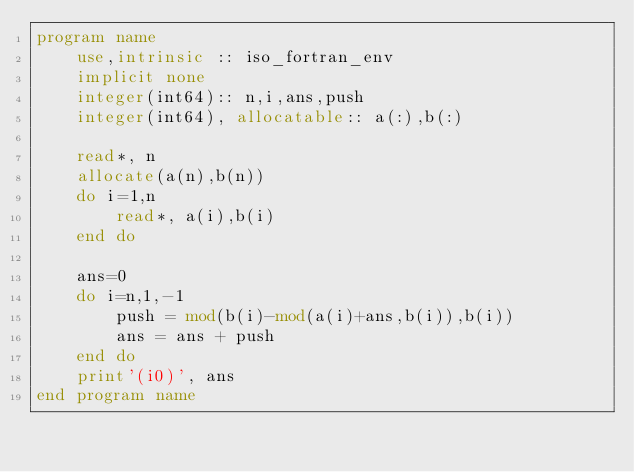Convert code to text. <code><loc_0><loc_0><loc_500><loc_500><_FORTRAN_>program name
    use,intrinsic :: iso_fortran_env
    implicit none
    integer(int64):: n,i,ans,push
    integer(int64), allocatable:: a(:),b(:)

    read*, n
    allocate(a(n),b(n))
    do i=1,n
        read*, a(i),b(i)
    end do

    ans=0
    do i=n,1,-1
        push = mod(b(i)-mod(a(i)+ans,b(i)),b(i))
        ans = ans + push
    end do
    print'(i0)', ans
end program name</code> 